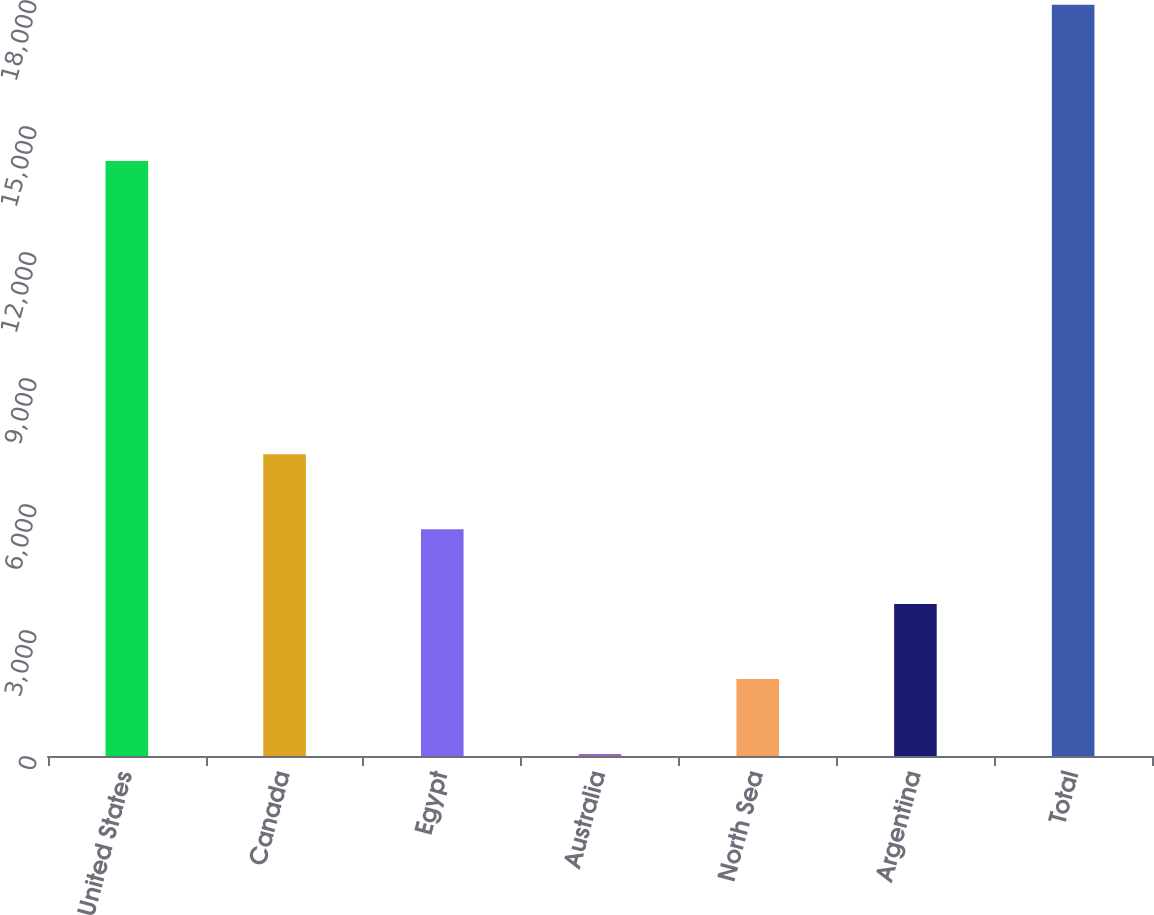<chart> <loc_0><loc_0><loc_500><loc_500><bar_chart><fcel>United States<fcel>Canada<fcel>Egypt<fcel>Australia<fcel>North Sea<fcel>Argentina<fcel>Total<nl><fcel>14164<fcel>7185<fcel>5401<fcel>49<fcel>1833<fcel>3617<fcel>17889<nl></chart> 